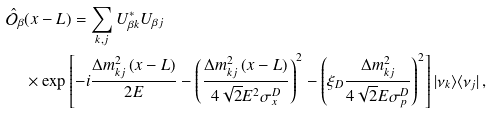<formula> <loc_0><loc_0><loc_500><loc_500>\hat { \mathcal { O } } _ { \beta } & ( x - L ) = \sum _ { k , j } U _ { \beta k } ^ { * } U _ { \beta j } \\ & \times \exp \left [ - i \frac { \Delta { m } ^ { 2 } _ { k j } \left ( x - L \right ) } { 2 E } - \left ( \frac { \Delta { m } ^ { 2 } _ { k j } \left ( x - L \right ) } { 4 \sqrt { 2 } E ^ { 2 } \sigma _ { x } ^ { D } } \right ) ^ { 2 } - \left ( \xi _ { D } \frac { \Delta { m } ^ { 2 } _ { k j } } { 4 \sqrt { 2 } E \sigma _ { p } ^ { D } } \right ) ^ { 2 } \right ] | \nu _ { k } \rangle \langle \nu _ { j } | \, ,</formula> 